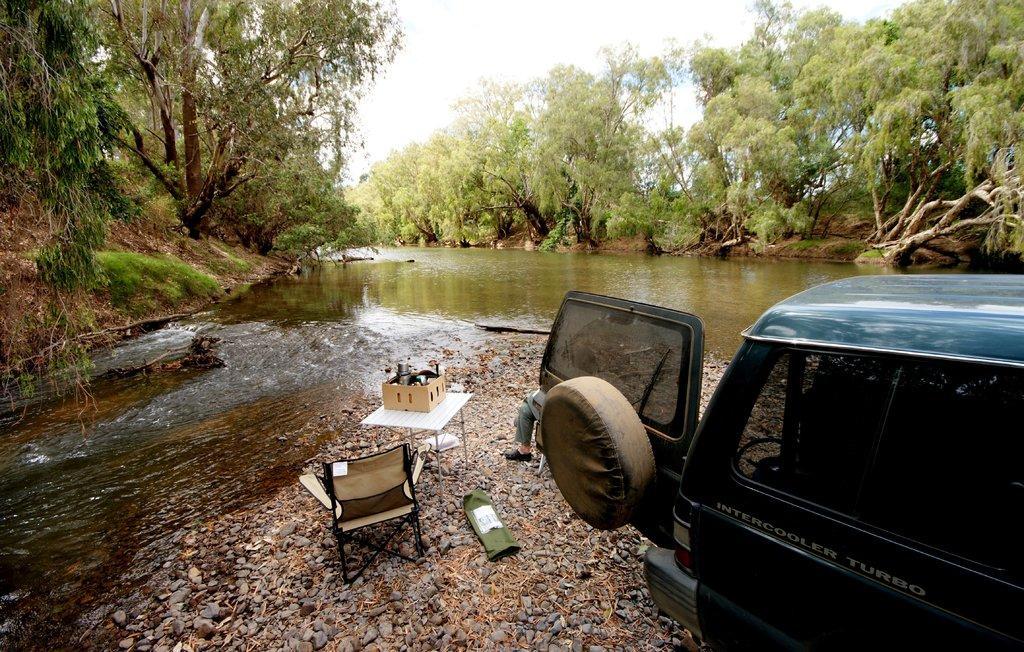Can you describe this image briefly? We can see water,trees and sky. We can see vehicle,chair. There is a table. On the table we can see thing. 